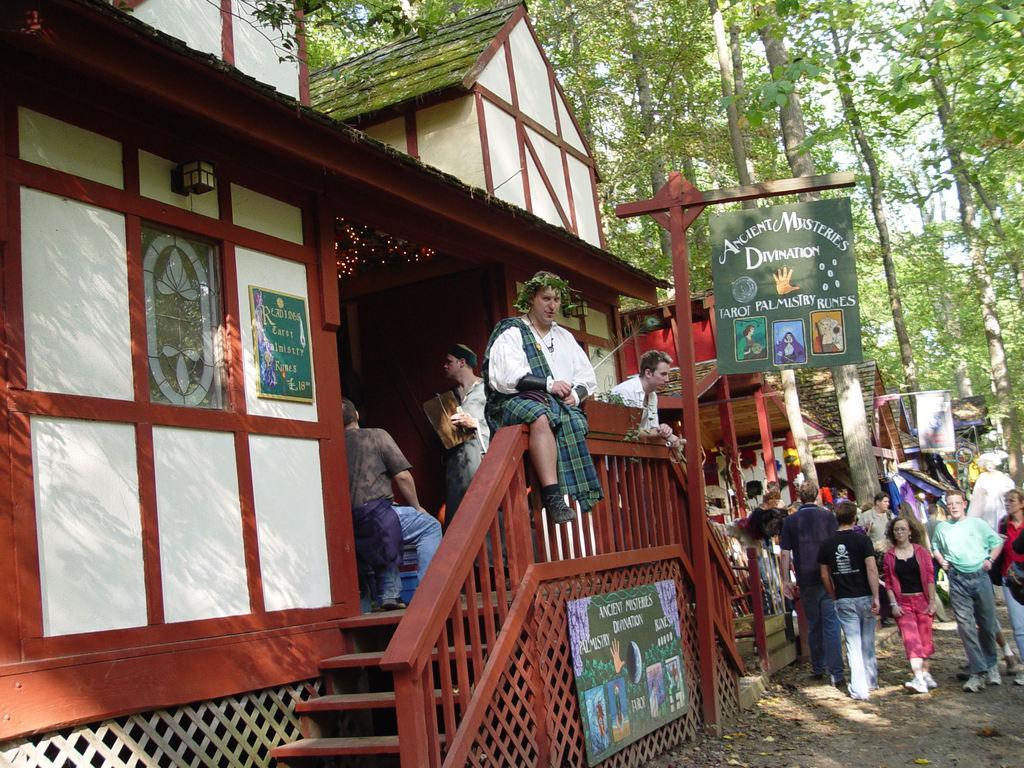How would you summarize this image in a sentence or two? In this image we can see some houses, some banners, some people are sitting, some boards with some text and images. There is one light attached to the wall, some objects are on the surface, some people are walking, some people are standing and some people are holding some objects. Some trees, one plant pot, some dried leaves on the surface and at the top there is the sky. 